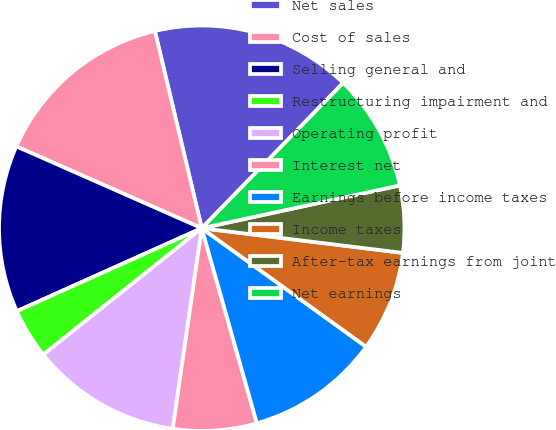Convert chart to OTSL. <chart><loc_0><loc_0><loc_500><loc_500><pie_chart><fcel>Net sales<fcel>Cost of sales<fcel>Selling general and<fcel>Restructuring impairment and<fcel>Operating profit<fcel>Interest net<fcel>Earnings before income taxes<fcel>Income taxes<fcel>After-tax earnings from joint<fcel>Net earnings<nl><fcel>16.0%<fcel>14.67%<fcel>13.33%<fcel>4.0%<fcel>12.0%<fcel>6.67%<fcel>10.67%<fcel>8.0%<fcel>5.33%<fcel>9.33%<nl></chart> 